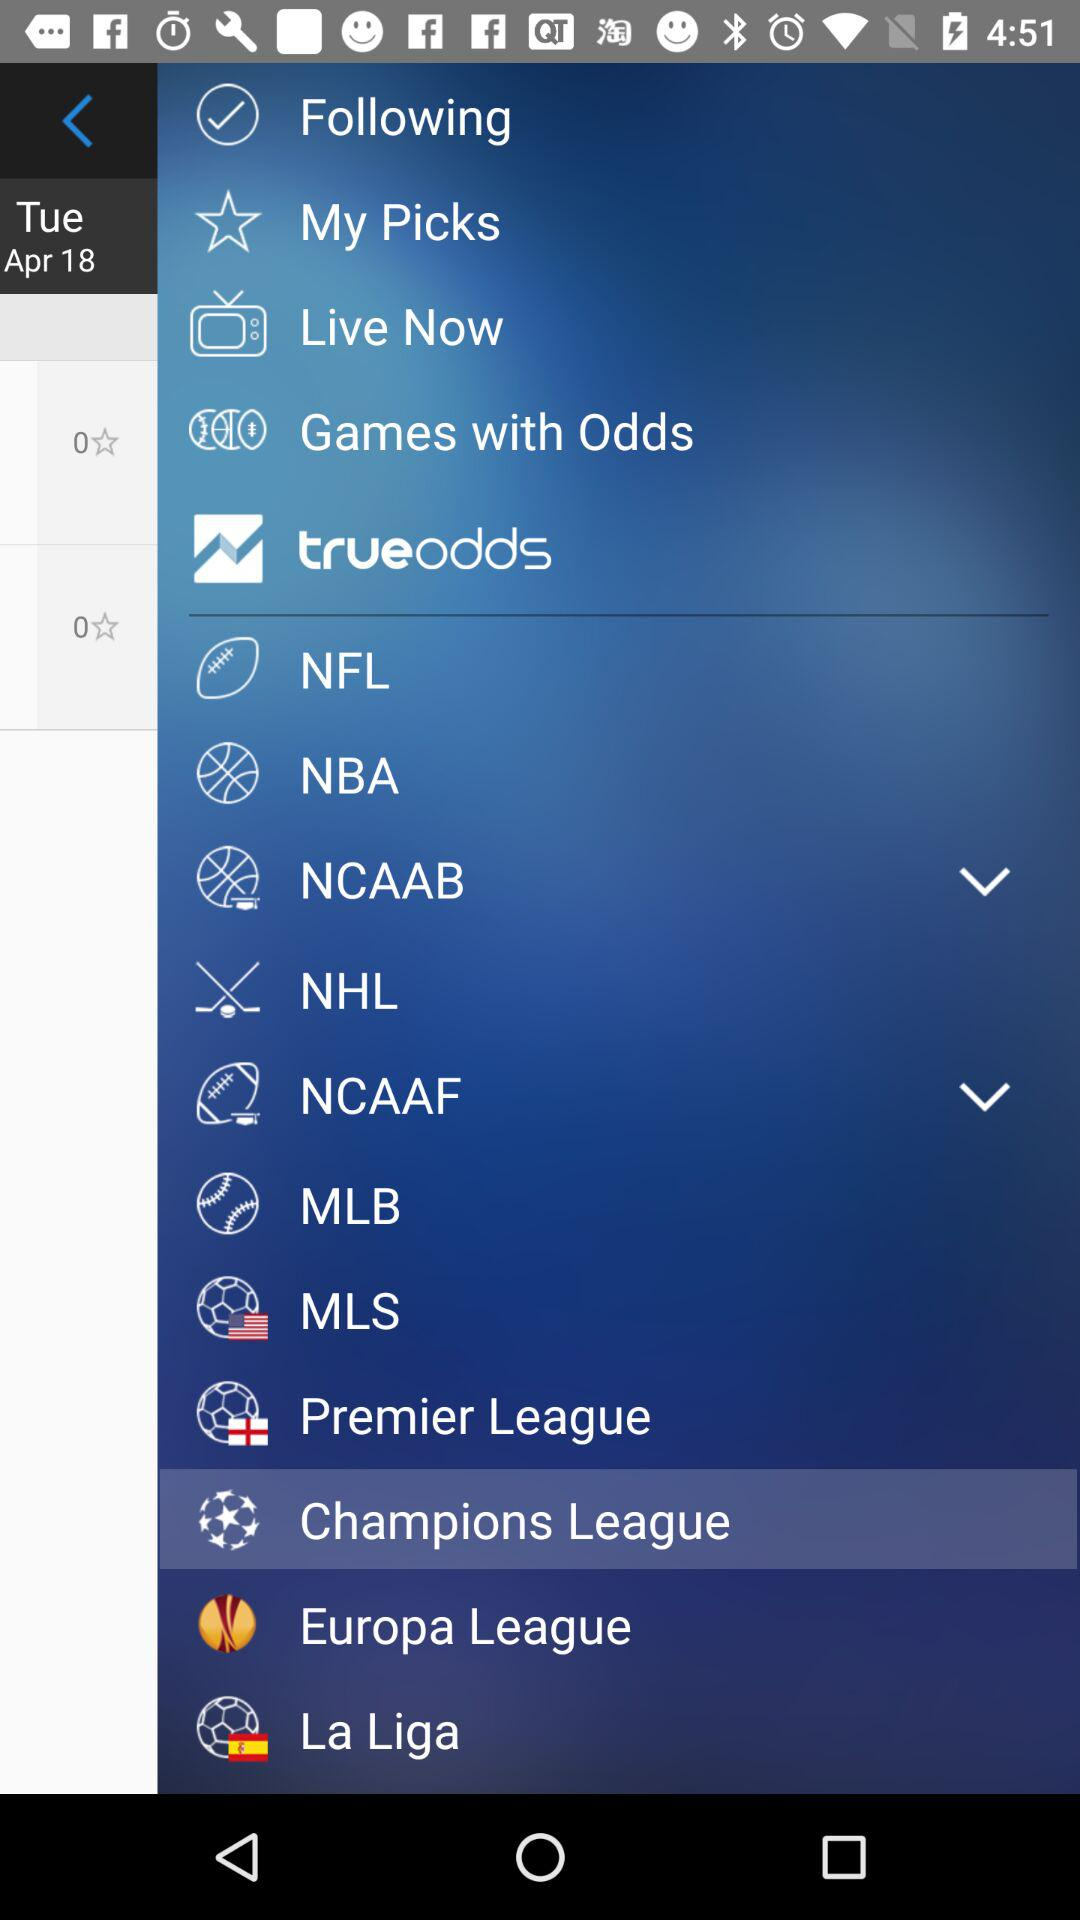What date is given? The given date is Tuesday, April 18. 